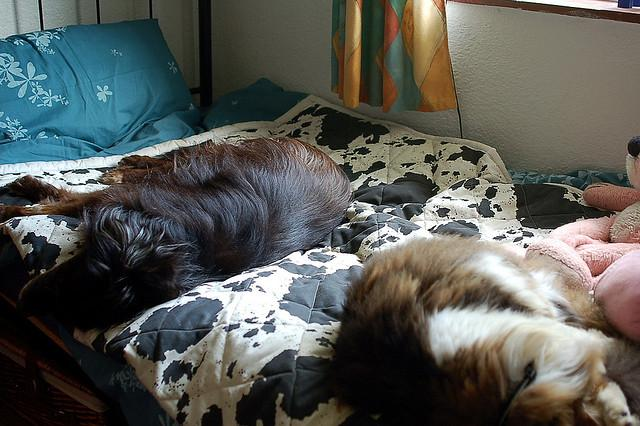Who is the bed for? dog 